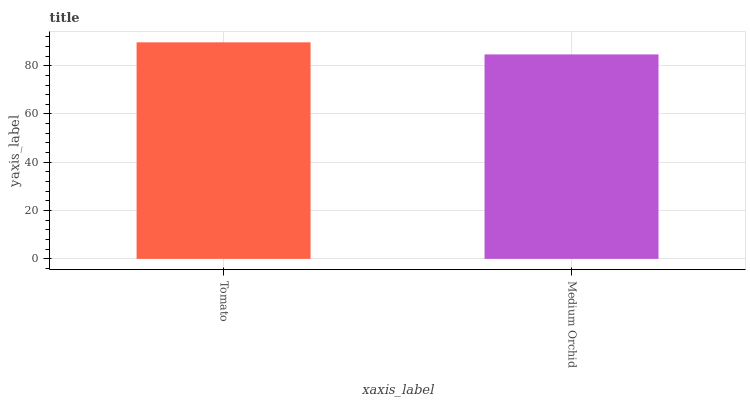Is Medium Orchid the minimum?
Answer yes or no. Yes. Is Tomato the maximum?
Answer yes or no. Yes. Is Medium Orchid the maximum?
Answer yes or no. No. Is Tomato greater than Medium Orchid?
Answer yes or no. Yes. Is Medium Orchid less than Tomato?
Answer yes or no. Yes. Is Medium Orchid greater than Tomato?
Answer yes or no. No. Is Tomato less than Medium Orchid?
Answer yes or no. No. Is Tomato the high median?
Answer yes or no. Yes. Is Medium Orchid the low median?
Answer yes or no. Yes. Is Medium Orchid the high median?
Answer yes or no. No. Is Tomato the low median?
Answer yes or no. No. 